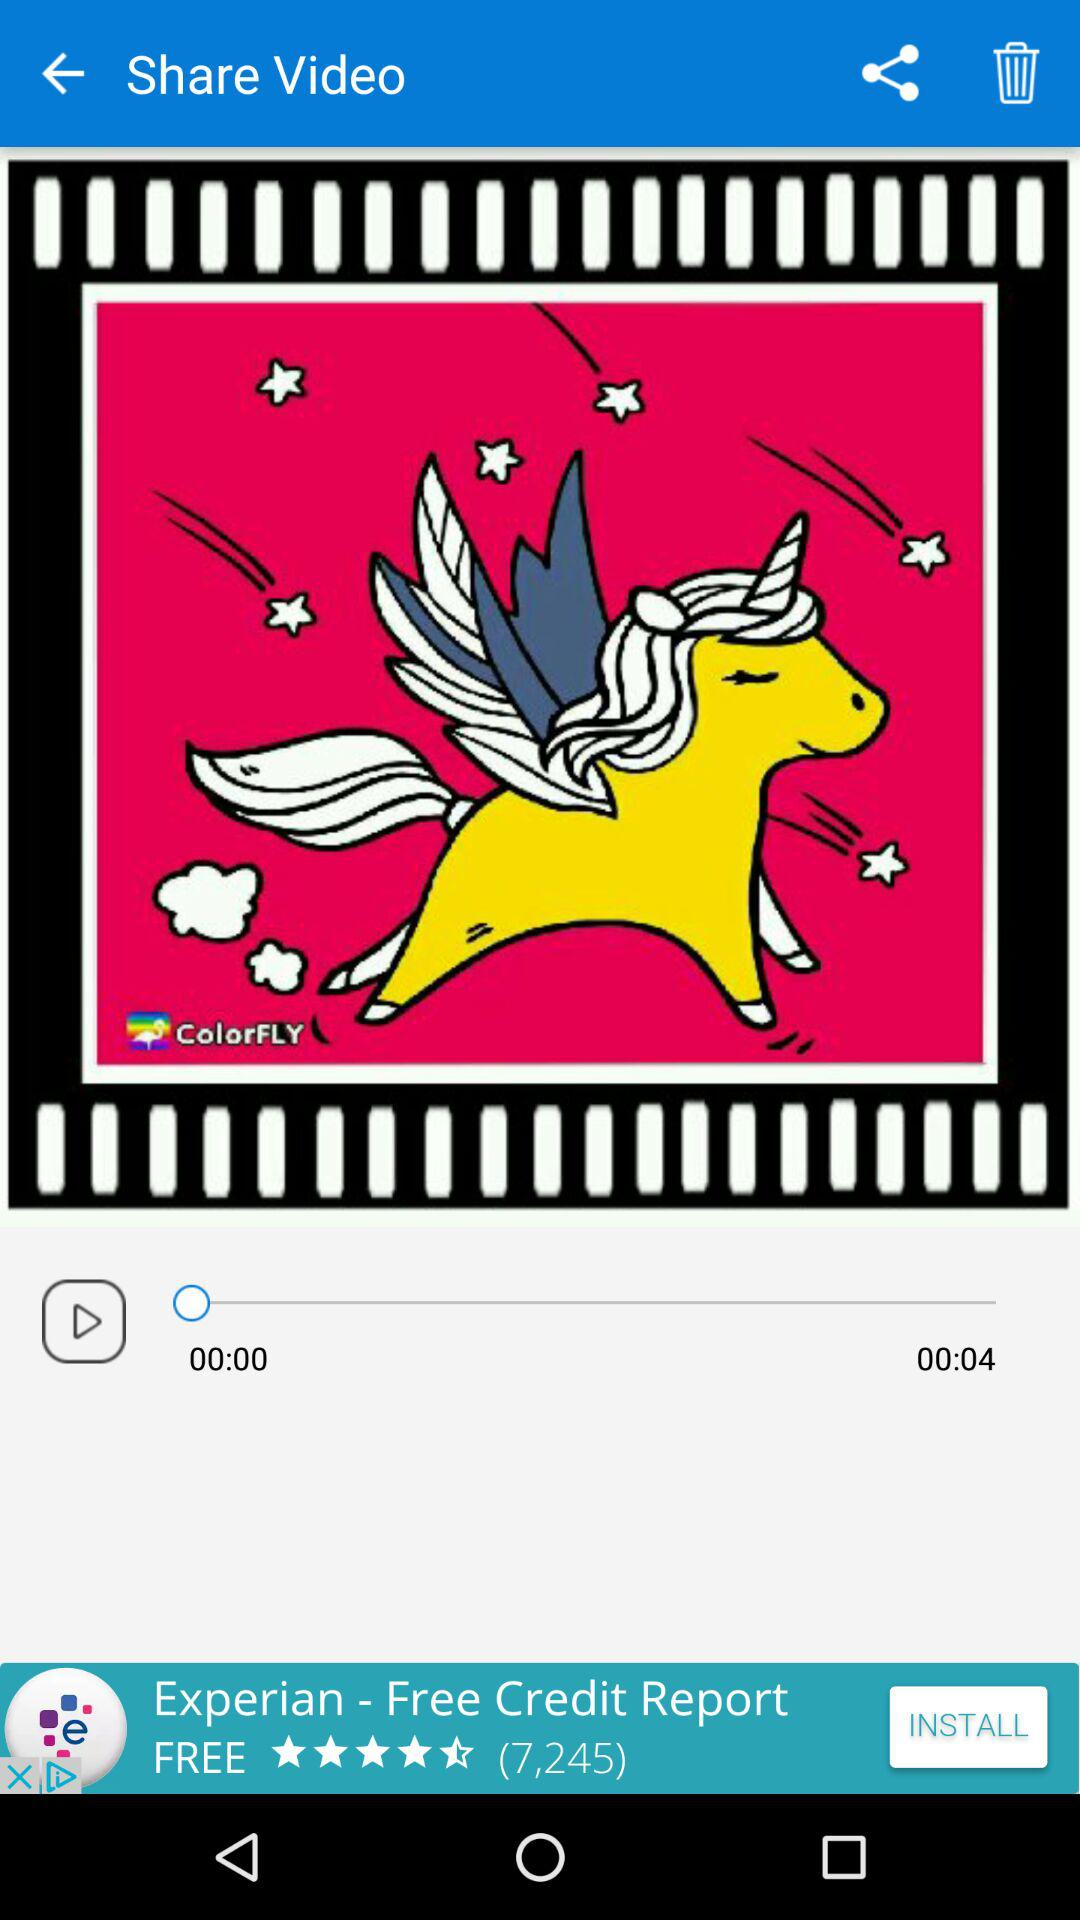What is the duration of the video? The duration is 4 seconds. 